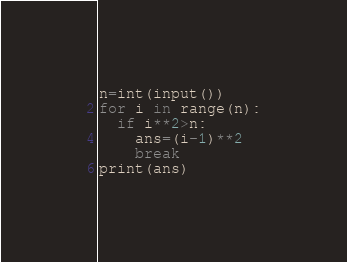Convert code to text. <code><loc_0><loc_0><loc_500><loc_500><_Python_>n=int(input())
for i in range(n):
  if i**2>n:
    ans=(i-1)**2
    break
print(ans)</code> 